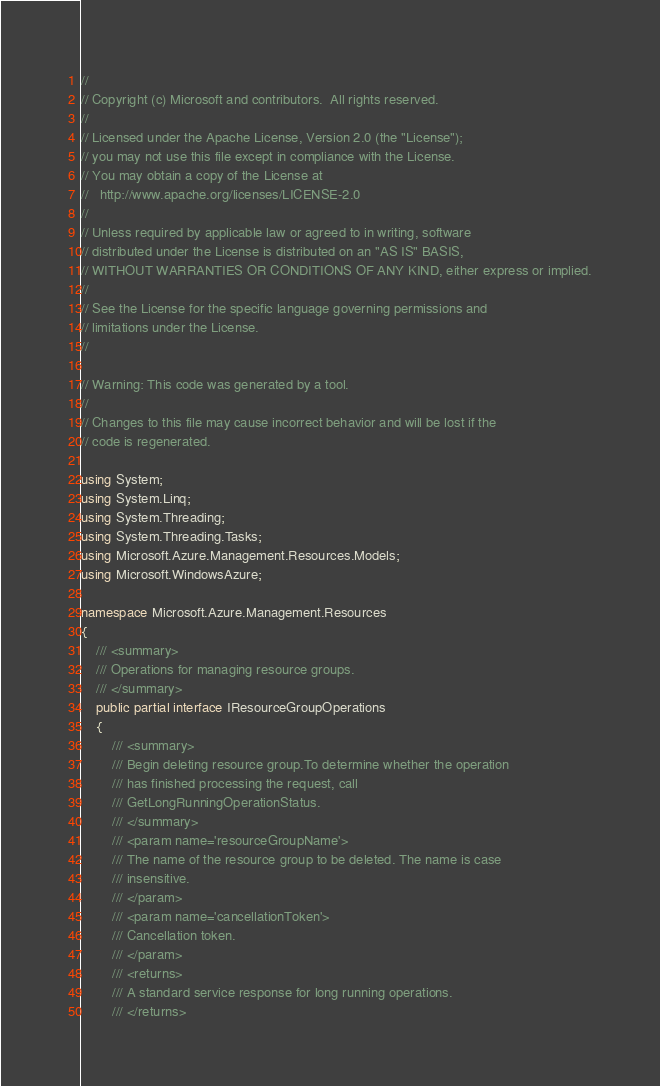Convert code to text. <code><loc_0><loc_0><loc_500><loc_500><_C#_>// 
// Copyright (c) Microsoft and contributors.  All rights reserved.
// 
// Licensed under the Apache License, Version 2.0 (the "License");
// you may not use this file except in compliance with the License.
// You may obtain a copy of the License at
//   http://www.apache.org/licenses/LICENSE-2.0
// 
// Unless required by applicable law or agreed to in writing, software
// distributed under the License is distributed on an "AS IS" BASIS,
// WITHOUT WARRANTIES OR CONDITIONS OF ANY KIND, either express or implied.
// 
// See the License for the specific language governing permissions and
// limitations under the License.
// 

// Warning: This code was generated by a tool.
// 
// Changes to this file may cause incorrect behavior and will be lost if the
// code is regenerated.

using System;
using System.Linq;
using System.Threading;
using System.Threading.Tasks;
using Microsoft.Azure.Management.Resources.Models;
using Microsoft.WindowsAzure;

namespace Microsoft.Azure.Management.Resources
{
    /// <summary>
    /// Operations for managing resource groups.
    /// </summary>
    public partial interface IResourceGroupOperations
    {
        /// <summary>
        /// Begin deleting resource group.To determine whether the operation
        /// has finished processing the request, call
        /// GetLongRunningOperationStatus.
        /// </summary>
        /// <param name='resourceGroupName'>
        /// The name of the resource group to be deleted. The name is case
        /// insensitive.
        /// </param>
        /// <param name='cancellationToken'>
        /// Cancellation token.
        /// </param>
        /// <returns>
        /// A standard service response for long running operations.
        /// </returns></code> 